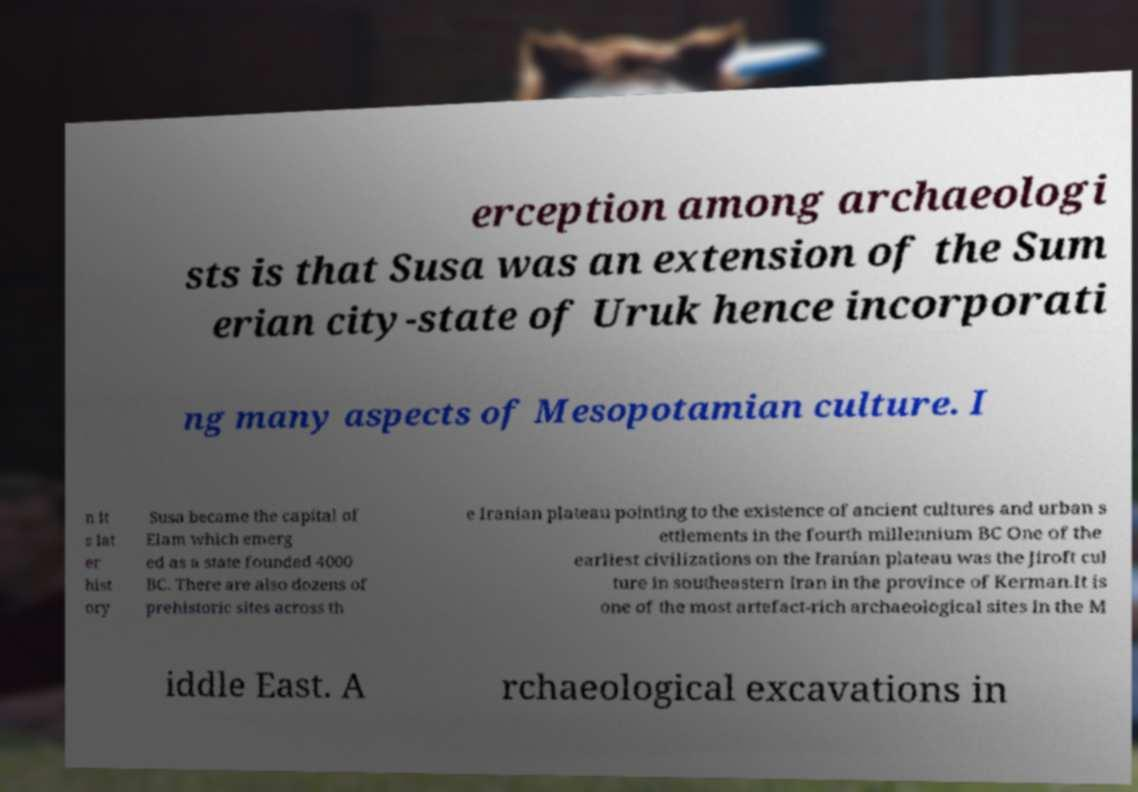Could you extract and type out the text from this image? erception among archaeologi sts is that Susa was an extension of the Sum erian city-state of Uruk hence incorporati ng many aspects of Mesopotamian culture. I n it s lat er hist ory Susa became the capital of Elam which emerg ed as a state founded 4000 BC. There are also dozens of prehistoric sites across th e Iranian plateau pointing to the existence of ancient cultures and urban s ettlements in the fourth millennium BC One of the earliest civilizations on the Iranian plateau was the Jiroft cul ture in southeastern Iran in the province of Kerman.It is one of the most artefact-rich archaeological sites in the M iddle East. A rchaeological excavations in 